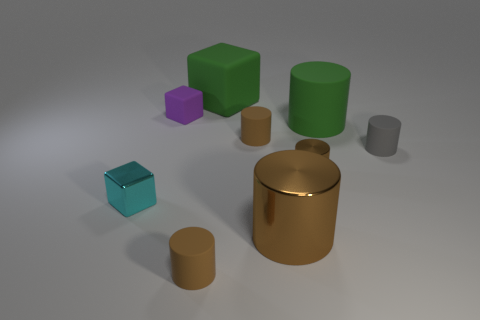Does the green rubber object to the left of the large brown cylinder have the same shape as the cyan metal object that is to the left of the large brown thing?
Ensure brevity in your answer.  Yes. What material is the green thing that is the same shape as the purple thing?
Give a very brief answer. Rubber. What shape is the matte object that is behind the matte cube that is on the left side of the green rubber block?
Offer a terse response. Cube. Is the material of the large cylinder in front of the metallic cube the same as the tiny gray cylinder?
Your response must be concise. No. Is the number of large brown cylinders that are to the left of the small purple rubber cube the same as the number of small shiny blocks in front of the large green cube?
Provide a short and direct response. No. What is the material of the large object that is the same color as the large block?
Your response must be concise. Rubber. What number of small metallic objects are left of the large object on the left side of the large shiny cylinder?
Give a very brief answer. 1. There is a rubber thing in front of the large brown object; is it the same color as the big matte thing that is in front of the green block?
Ensure brevity in your answer.  No. There is a cube that is the same size as the purple object; what material is it?
Your response must be concise. Metal. There is a big green thing behind the matte thing that is to the left of the small rubber cylinder in front of the tiny cyan cube; what is its shape?
Offer a terse response. Cube. 